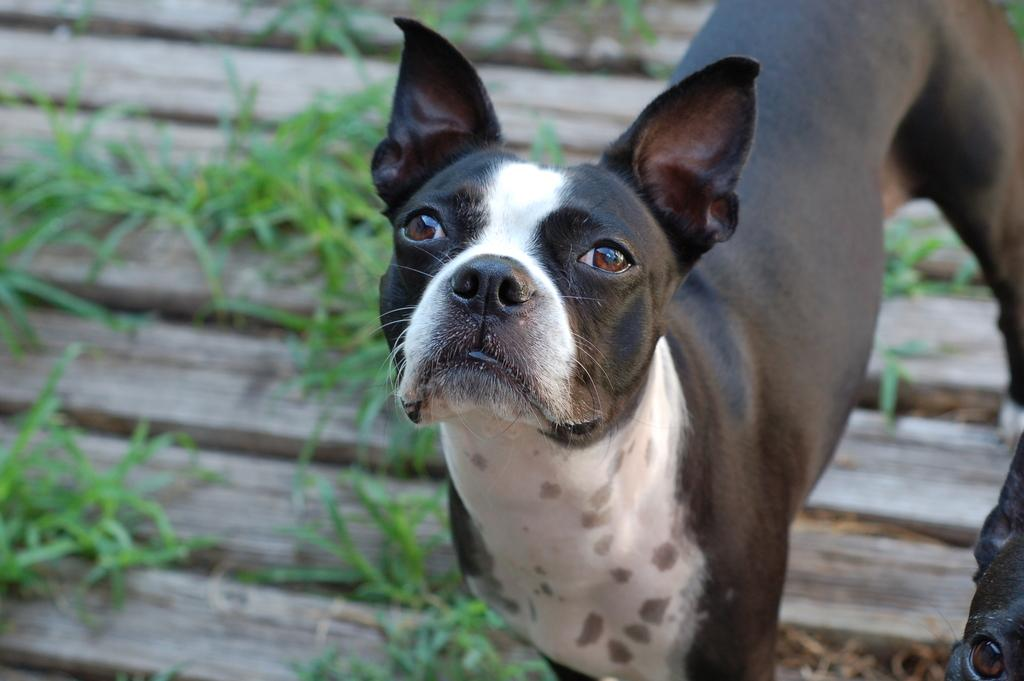What type of animal can be seen in the image? There is a black color dog in the image. What is the background of the image? There is grass visible in the image. How many brothers does the donkey have in the image? There is no donkey present in the image, so it is not possible to determine how many brothers the donkey might have. 